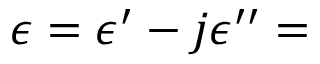Convert formula to latex. <formula><loc_0><loc_0><loc_500><loc_500>\epsilon = \epsilon ^ { \prime } - j \epsilon ^ { \prime \prime } =</formula> 